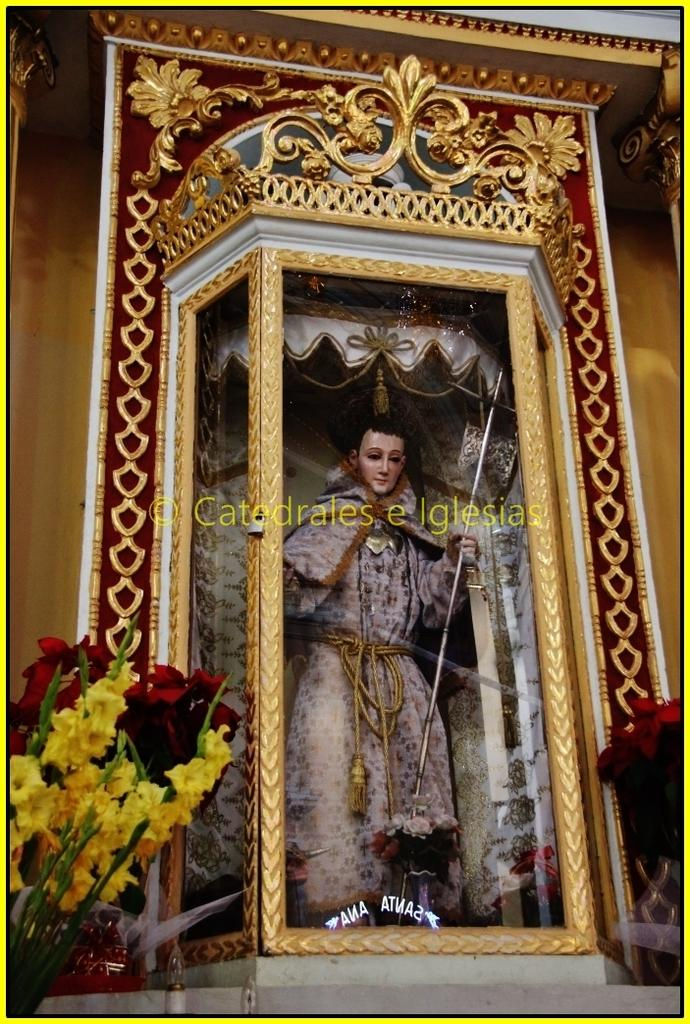What is the main subject of the image? The main subject of the image is a statue. Where is the statue located? The statue is in a decorative box. What other elements can be seen in the image? There are flowers in the image. What type of pot is used for watering the flowers in the image? There is no pot visible in the image, and the flowers do not appear to be watered. 